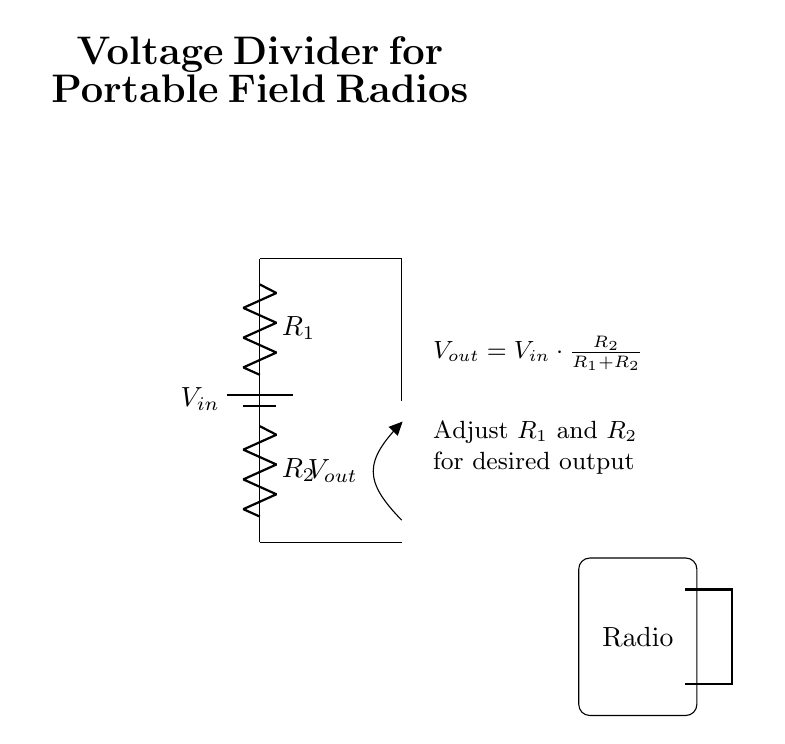What components are in the voltage divider circuit? The voltage divider circuit consists of a battery, two resistors labeled R1 and R2. These components are visible in the diagram.
Answer: Battery, R1, R2 What is the function of R1 in the circuit? R1, as part of the voltage divider, helps determine the proportion of input voltage that is output based on its resistance value relative to R2. It creates a voltage drop across it.
Answer: Voltage drop What does Vout represent in this circuit? Vout is the output voltage taken from the connection between R1 and R2. It is derived from the input voltage and the resistances of R1 and R2 using the voltage divider formula.
Answer: Output voltage How is Vout calculated in the circuit? Vout is calculated using the formula Vout equals Vin multiplied by R2 divided by the sum of R1 and R2. This reflects how resistances affect the output voltage.
Answer: Vout = Vin * (R2 / (R1 + R2)) If R2 is increased, what happens to Vout? Increasing R2 will result in a higher Vout, as the output voltage is directly proportional to R2. The reasoning is based on the voltage divider formula where increasing R2 increases the ratio.
Answer: Vout increases What is the purpose of the voltage divider in military operations? The voltage divider is used to reduce the voltage from a battery to a level that is suitable for portable field radios, ensuring safe operation and extended battery life.
Answer: Voltage reduction 